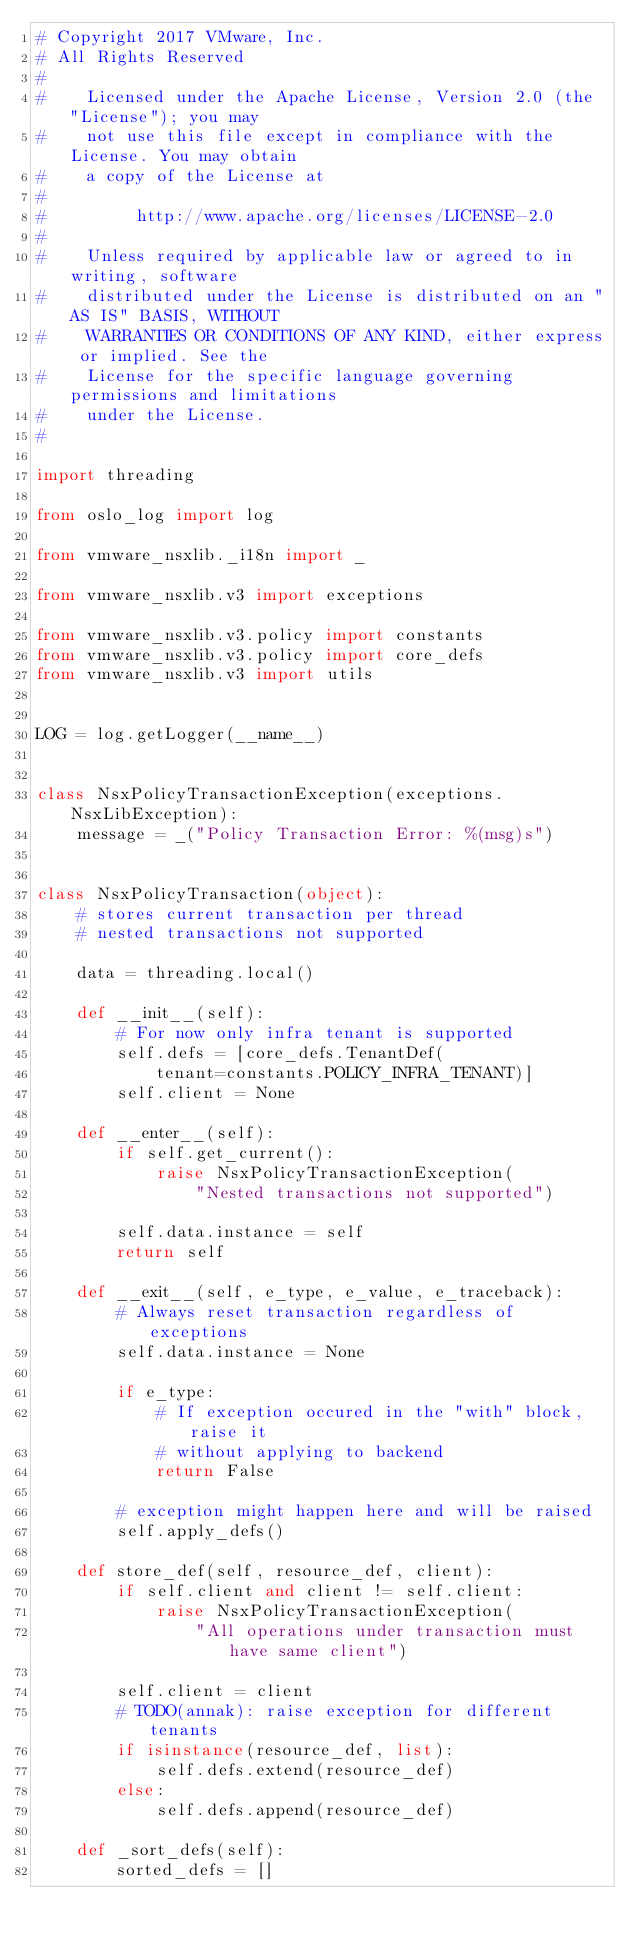<code> <loc_0><loc_0><loc_500><loc_500><_Python_># Copyright 2017 VMware, Inc.
# All Rights Reserved
#
#    Licensed under the Apache License, Version 2.0 (the "License"); you may
#    not use this file except in compliance with the License. You may obtain
#    a copy of the License at
#
#         http://www.apache.org/licenses/LICENSE-2.0
#
#    Unless required by applicable law or agreed to in writing, software
#    distributed under the License is distributed on an "AS IS" BASIS, WITHOUT
#    WARRANTIES OR CONDITIONS OF ANY KIND, either express or implied. See the
#    License for the specific language governing permissions and limitations
#    under the License.
#

import threading

from oslo_log import log

from vmware_nsxlib._i18n import _

from vmware_nsxlib.v3 import exceptions

from vmware_nsxlib.v3.policy import constants
from vmware_nsxlib.v3.policy import core_defs
from vmware_nsxlib.v3 import utils


LOG = log.getLogger(__name__)


class NsxPolicyTransactionException(exceptions.NsxLibException):
    message = _("Policy Transaction Error: %(msg)s")


class NsxPolicyTransaction(object):
    # stores current transaction per thread
    # nested transactions not supported

    data = threading.local()

    def __init__(self):
        # For now only infra tenant is supported
        self.defs = [core_defs.TenantDef(
            tenant=constants.POLICY_INFRA_TENANT)]
        self.client = None

    def __enter__(self):
        if self.get_current():
            raise NsxPolicyTransactionException(
                "Nested transactions not supported")

        self.data.instance = self
        return self

    def __exit__(self, e_type, e_value, e_traceback):
        # Always reset transaction regardless of exceptions
        self.data.instance = None

        if e_type:
            # If exception occured in the "with" block, raise it
            # without applying to backend
            return False

        # exception might happen here and will be raised
        self.apply_defs()

    def store_def(self, resource_def, client):
        if self.client and client != self.client:
            raise NsxPolicyTransactionException(
                "All operations under transaction must have same client")

        self.client = client
        # TODO(annak): raise exception for different tenants
        if isinstance(resource_def, list):
            self.defs.extend(resource_def)
        else:
            self.defs.append(resource_def)

    def _sort_defs(self):
        sorted_defs = []
</code> 